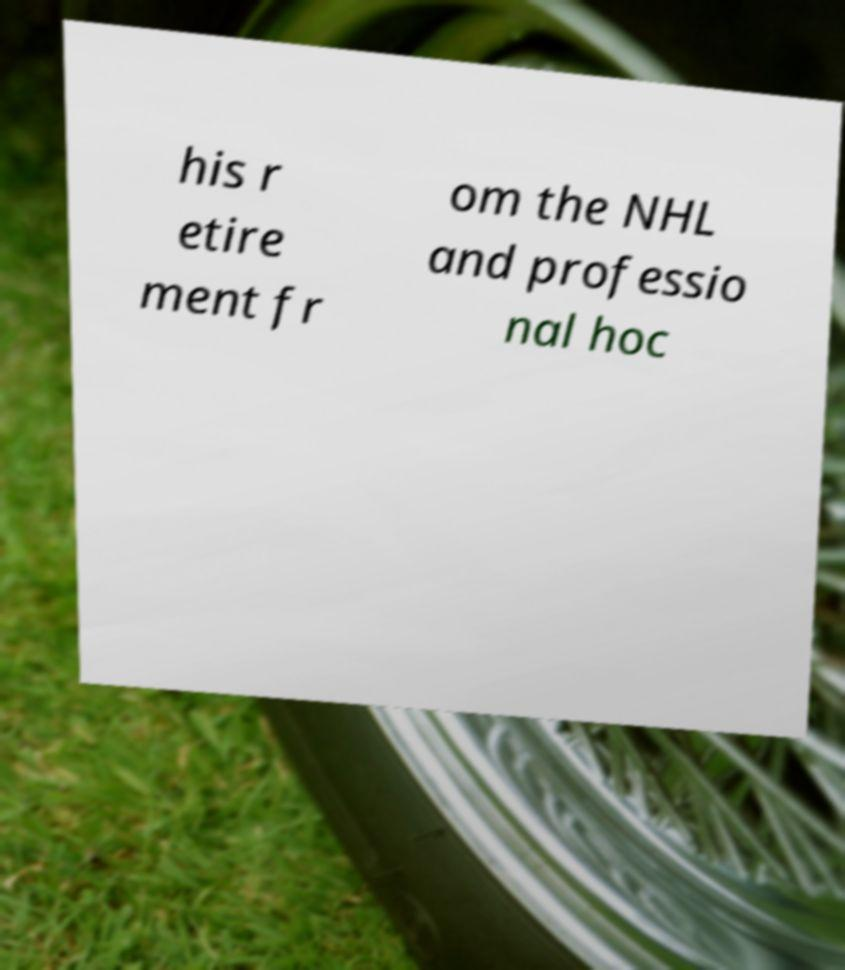Can you accurately transcribe the text from the provided image for me? his r etire ment fr om the NHL and professio nal hoc 